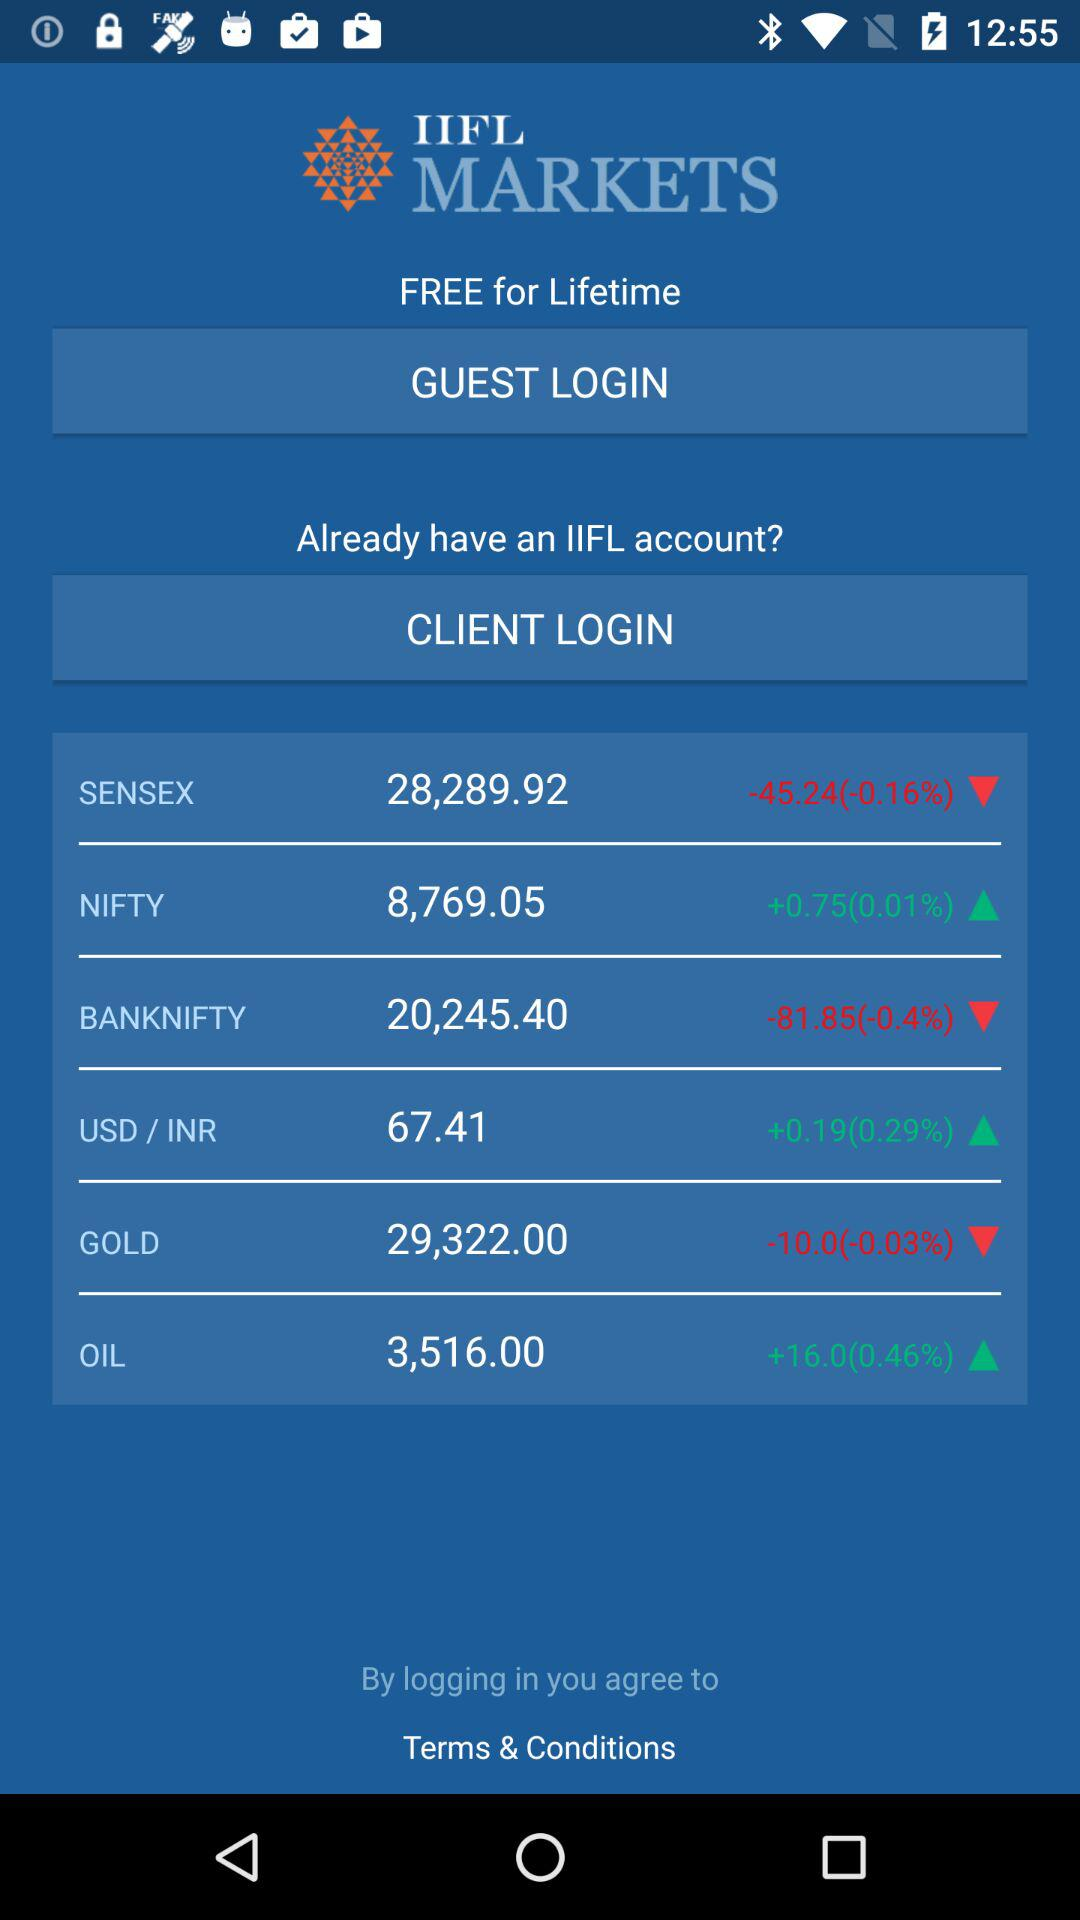What is the percentage decrease in "GOLD"? The percentage decrease in "GOLD" is 0.03. 